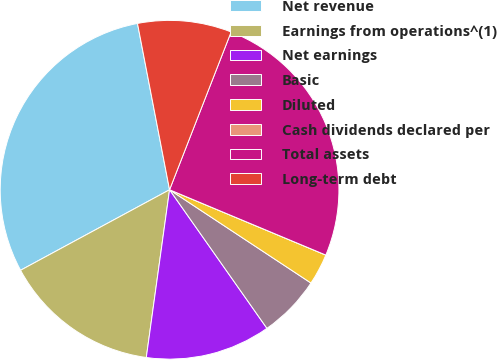Convert chart to OTSL. <chart><loc_0><loc_0><loc_500><loc_500><pie_chart><fcel>Net revenue<fcel>Earnings from operations^(1)<fcel>Net earnings<fcel>Basic<fcel>Diluted<fcel>Cash dividends declared per<fcel>Total assets<fcel>Long-term debt<nl><fcel>29.85%<fcel>14.92%<fcel>11.94%<fcel>5.97%<fcel>2.98%<fcel>0.0%<fcel>25.38%<fcel>8.95%<nl></chart> 